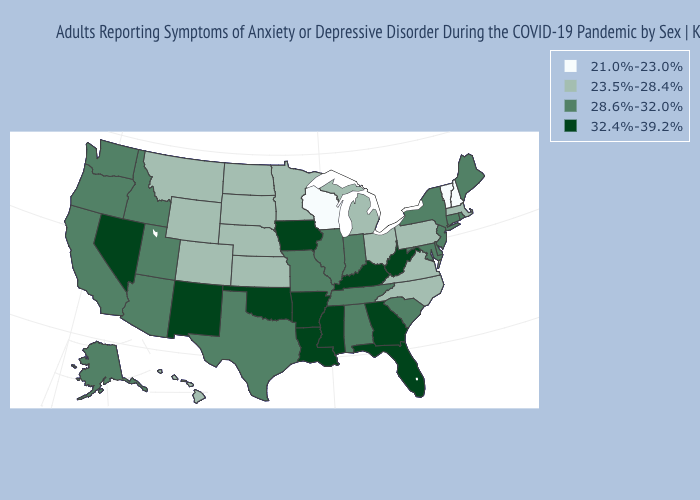Is the legend a continuous bar?
Answer briefly. No. What is the lowest value in the USA?
Write a very short answer. 21.0%-23.0%. Does Nebraska have a lower value than Texas?
Answer briefly. Yes. What is the value of New Hampshire?
Quick response, please. 21.0%-23.0%. Name the states that have a value in the range 23.5%-28.4%?
Quick response, please. Colorado, Hawaii, Kansas, Massachusetts, Michigan, Minnesota, Montana, Nebraska, North Carolina, North Dakota, Ohio, Pennsylvania, South Dakota, Virginia, Wyoming. What is the value of California?
Concise answer only. 28.6%-32.0%. Does Vermont have the lowest value in the USA?
Keep it brief. Yes. Does Florida have the highest value in the USA?
Give a very brief answer. Yes. Among the states that border Florida , which have the lowest value?
Write a very short answer. Alabama. What is the lowest value in states that border Iowa?
Short answer required. 21.0%-23.0%. What is the value of Nebraska?
Answer briefly. 23.5%-28.4%. What is the highest value in states that border Michigan?
Keep it brief. 28.6%-32.0%. Name the states that have a value in the range 28.6%-32.0%?
Be succinct. Alabama, Alaska, Arizona, California, Connecticut, Delaware, Idaho, Illinois, Indiana, Maine, Maryland, Missouri, New Jersey, New York, Oregon, Rhode Island, South Carolina, Tennessee, Texas, Utah, Washington. Does Michigan have the lowest value in the MidWest?
Short answer required. No. 